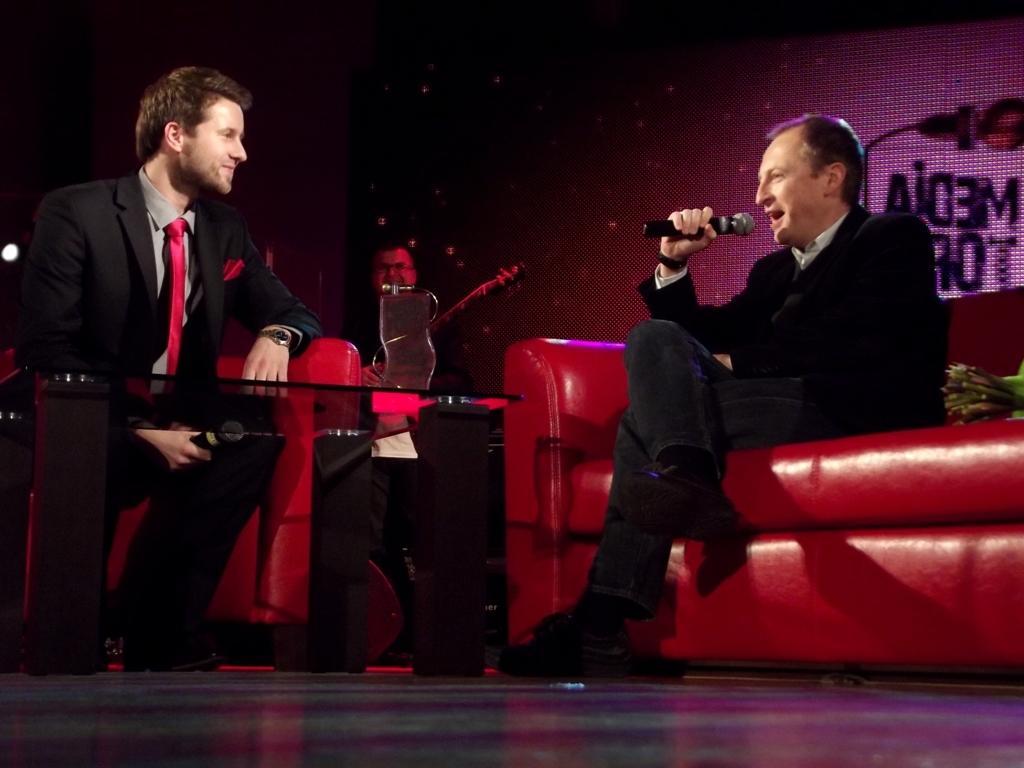Can you describe this image briefly? In this picture we can see few people, two people are seated on the sofas, and they are holding microphones, in front of them we can see a shield on the table. 